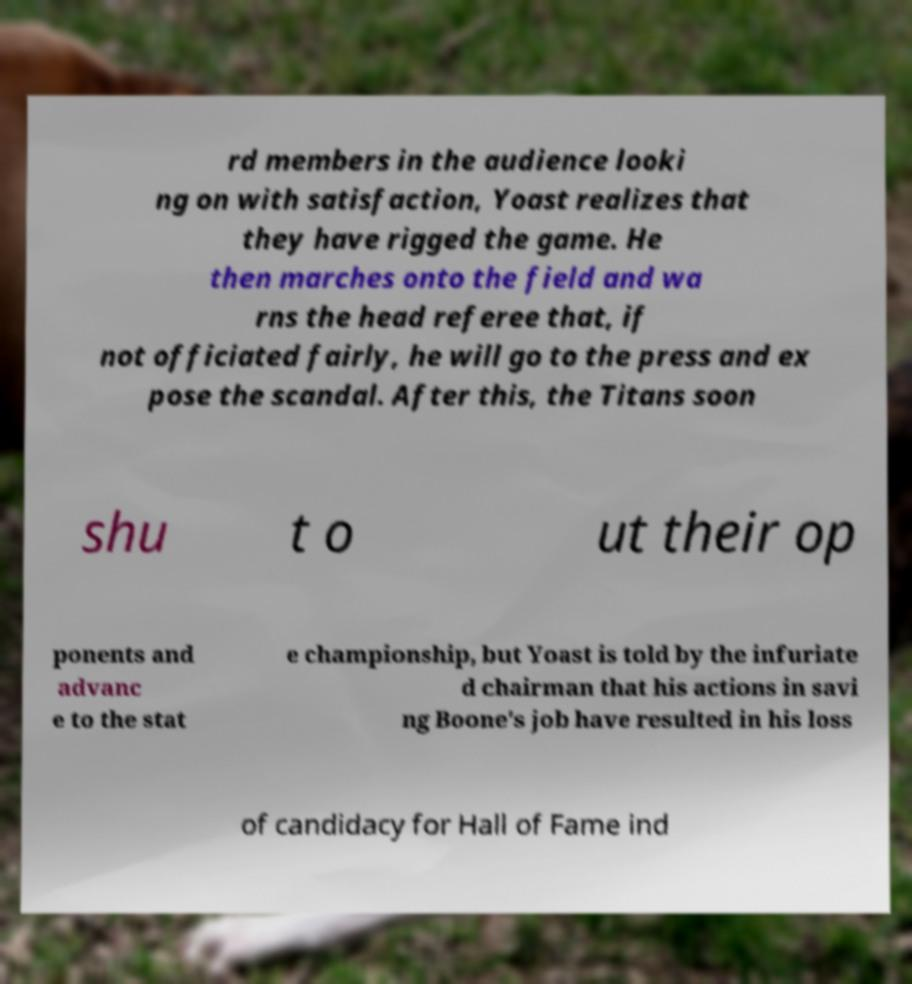Can you read and provide the text displayed in the image?This photo seems to have some interesting text. Can you extract and type it out for me? rd members in the audience looki ng on with satisfaction, Yoast realizes that they have rigged the game. He then marches onto the field and wa rns the head referee that, if not officiated fairly, he will go to the press and ex pose the scandal. After this, the Titans soon shu t o ut their op ponents and advanc e to the stat e championship, but Yoast is told by the infuriate d chairman that his actions in savi ng Boone's job have resulted in his loss of candidacy for Hall of Fame ind 